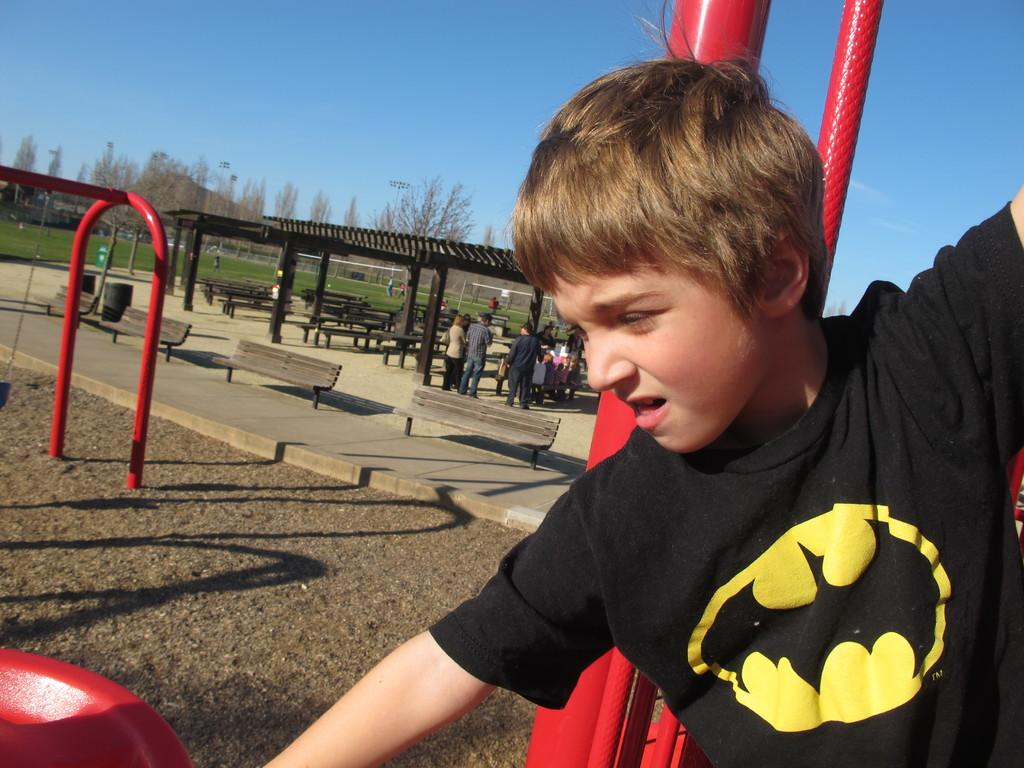What type of vegetation can be seen in the image? There are trees in the image. What are the people in the image doing? There are people standing in the image. What type of seating is available in the image? There are benches in the image. Can you describe the boy in the image? There is a boy in the image. What is the ground covered with in the image? There is grass on the ground in the image. What color is the sky in the image? The sky is blue in the image. What type of material is used for the metal rods in the image? There are metal rods in the image. What effect does the boy's uncle have on the neck of the person sitting on the bench in the image? There is no mention of an uncle or any effect on a person's neck in the image. 